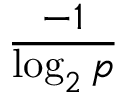Convert formula to latex. <formula><loc_0><loc_0><loc_500><loc_500>\frac { - 1 } { \log _ { 2 } p }</formula> 